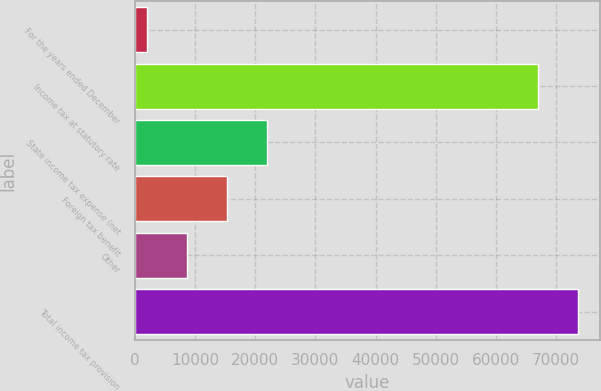Convert chart to OTSL. <chart><loc_0><loc_0><loc_500><loc_500><bar_chart><fcel>For the years ended December<fcel>Income tax at statutory rate<fcel>State income tax expense (net<fcel>Foreign tax benefit<fcel>Other<fcel>Total income tax provision<nl><fcel>2013<fcel>67063<fcel>21891.9<fcel>15265.6<fcel>8639.3<fcel>73689.3<nl></chart> 